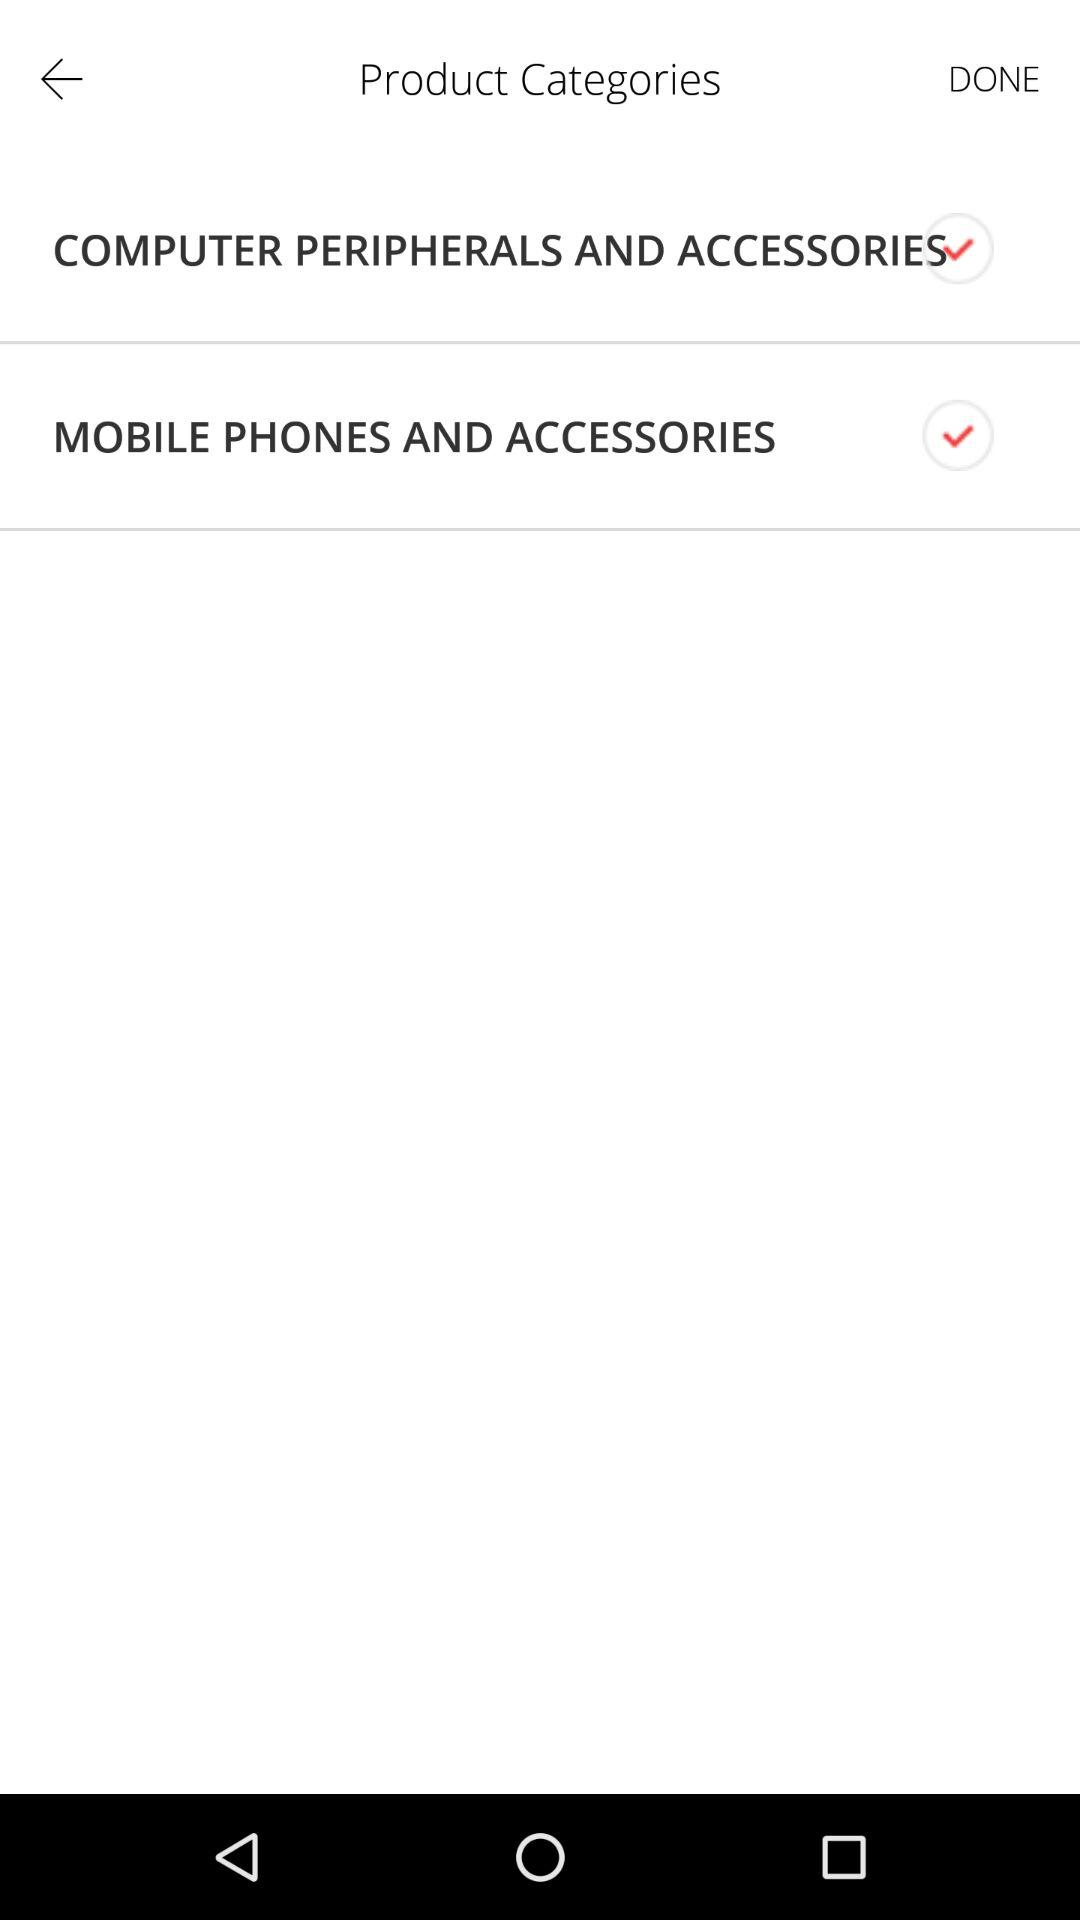How many checkboxes are checked?
Answer the question using a single word or phrase. 2 